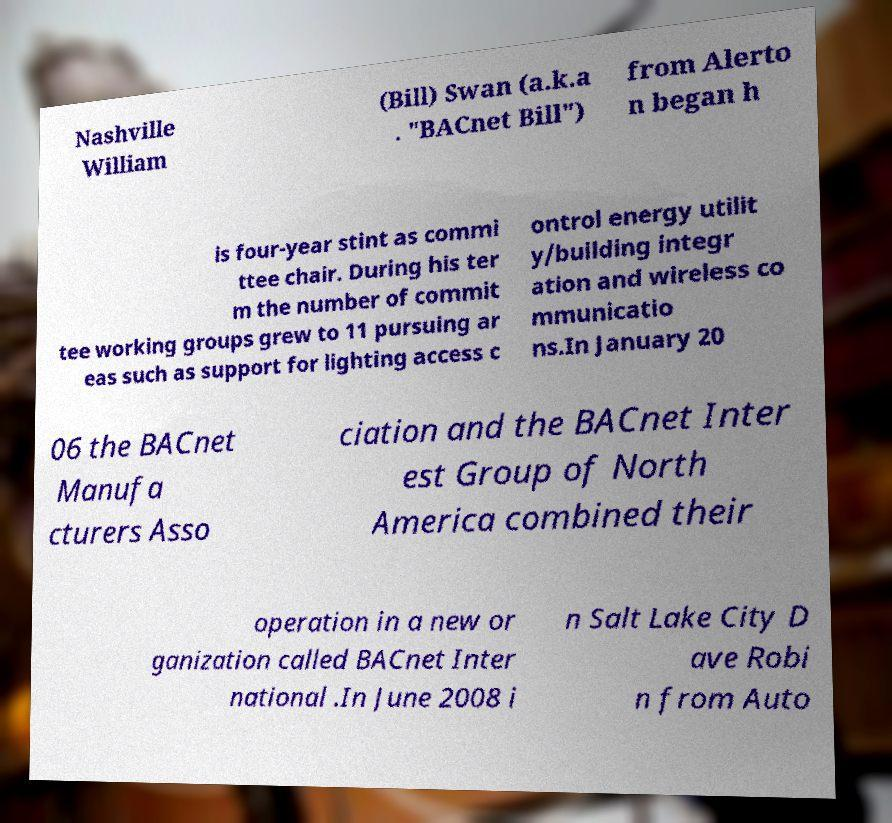Please identify and transcribe the text found in this image. Nashville William (Bill) Swan (a.k.a . "BACnet Bill") from Alerto n began h is four-year stint as commi ttee chair. During his ter m the number of commit tee working groups grew to 11 pursuing ar eas such as support for lighting access c ontrol energy utilit y/building integr ation and wireless co mmunicatio ns.In January 20 06 the BACnet Manufa cturers Asso ciation and the BACnet Inter est Group of North America combined their operation in a new or ganization called BACnet Inter national .In June 2008 i n Salt Lake City D ave Robi n from Auto 